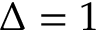<formula> <loc_0><loc_0><loc_500><loc_500>\Delta = 1</formula> 